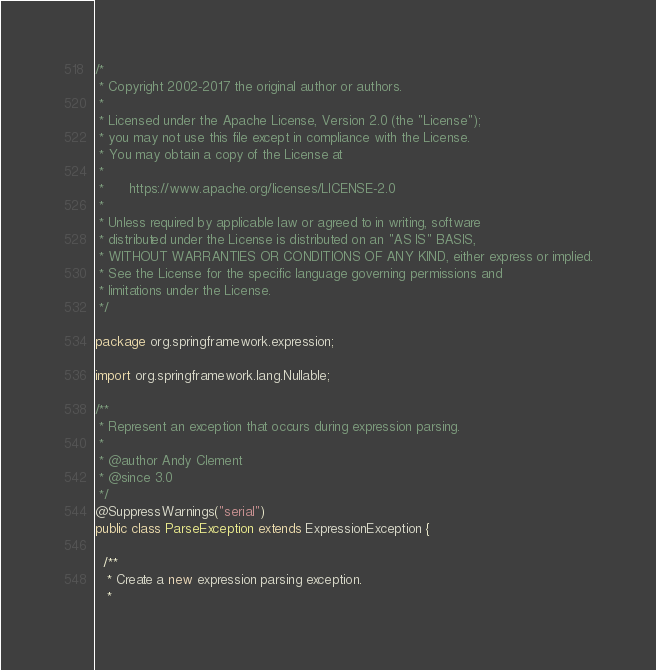<code> <loc_0><loc_0><loc_500><loc_500><_Java_>/*
 * Copyright 2002-2017 the original author or authors.
 *
 * Licensed under the Apache License, Version 2.0 (the "License");
 * you may not use this file except in compliance with the License.
 * You may obtain a copy of the License at
 *
 *      https://www.apache.org/licenses/LICENSE-2.0
 *
 * Unless required by applicable law or agreed to in writing, software
 * distributed under the License is distributed on an "AS IS" BASIS,
 * WITHOUT WARRANTIES OR CONDITIONS OF ANY KIND, either express or implied.
 * See the License for the specific language governing permissions and
 * limitations under the License.
 */

package org.springframework.expression;

import org.springframework.lang.Nullable;

/**
 * Represent an exception that occurs during expression parsing.
 *
 * @author Andy Clement
 * @since 3.0
 */
@SuppressWarnings("serial")
public class ParseException extends ExpressionException {

  /**
   * Create a new expression parsing exception.
   *</code> 